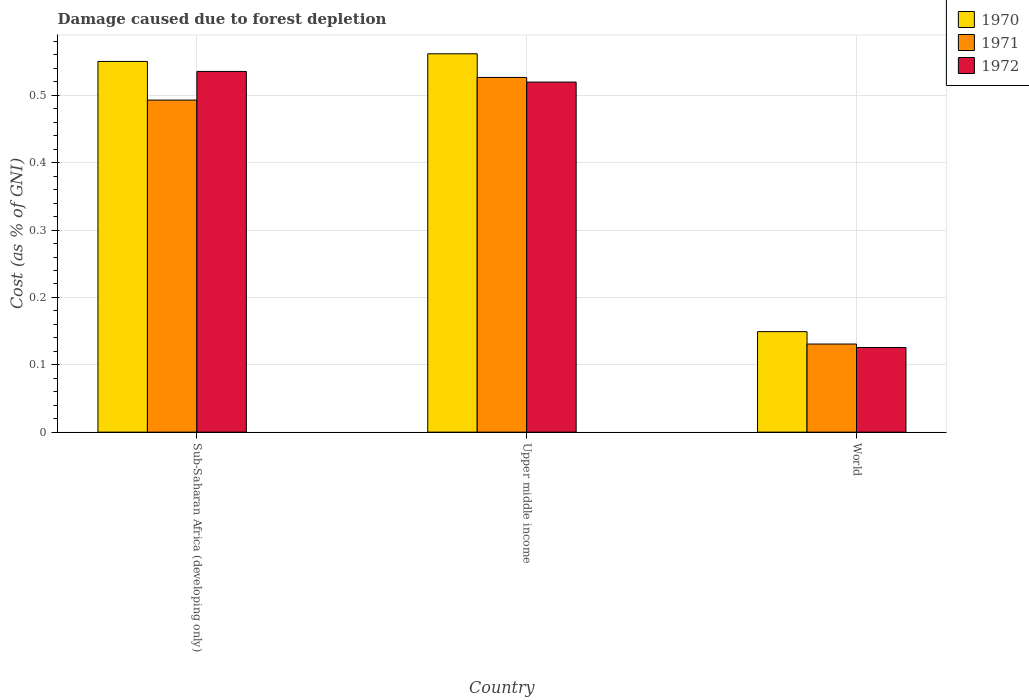How many different coloured bars are there?
Make the answer very short. 3. How many groups of bars are there?
Your answer should be compact. 3. Are the number of bars per tick equal to the number of legend labels?
Your answer should be compact. Yes. How many bars are there on the 2nd tick from the left?
Make the answer very short. 3. How many bars are there on the 2nd tick from the right?
Your answer should be compact. 3. What is the label of the 3rd group of bars from the left?
Your answer should be very brief. World. What is the cost of damage caused due to forest depletion in 1971 in Sub-Saharan Africa (developing only)?
Your answer should be compact. 0.49. Across all countries, what is the maximum cost of damage caused due to forest depletion in 1971?
Provide a succinct answer. 0.53. Across all countries, what is the minimum cost of damage caused due to forest depletion in 1971?
Keep it short and to the point. 0.13. In which country was the cost of damage caused due to forest depletion in 1972 maximum?
Give a very brief answer. Sub-Saharan Africa (developing only). What is the total cost of damage caused due to forest depletion in 1971 in the graph?
Ensure brevity in your answer.  1.15. What is the difference between the cost of damage caused due to forest depletion in 1970 in Upper middle income and that in World?
Provide a succinct answer. 0.41. What is the difference between the cost of damage caused due to forest depletion in 1970 in Sub-Saharan Africa (developing only) and the cost of damage caused due to forest depletion in 1971 in World?
Offer a very short reply. 0.42. What is the average cost of damage caused due to forest depletion in 1970 per country?
Make the answer very short. 0.42. What is the difference between the cost of damage caused due to forest depletion of/in 1971 and cost of damage caused due to forest depletion of/in 1970 in Sub-Saharan Africa (developing only)?
Provide a succinct answer. -0.06. What is the ratio of the cost of damage caused due to forest depletion in 1972 in Upper middle income to that in World?
Keep it short and to the point. 4.14. Is the difference between the cost of damage caused due to forest depletion in 1971 in Sub-Saharan Africa (developing only) and World greater than the difference between the cost of damage caused due to forest depletion in 1970 in Sub-Saharan Africa (developing only) and World?
Make the answer very short. No. What is the difference between the highest and the second highest cost of damage caused due to forest depletion in 1970?
Give a very brief answer. 0.01. What is the difference between the highest and the lowest cost of damage caused due to forest depletion in 1972?
Your answer should be compact. 0.41. In how many countries, is the cost of damage caused due to forest depletion in 1972 greater than the average cost of damage caused due to forest depletion in 1972 taken over all countries?
Ensure brevity in your answer.  2. Is the sum of the cost of damage caused due to forest depletion in 1970 in Sub-Saharan Africa (developing only) and Upper middle income greater than the maximum cost of damage caused due to forest depletion in 1971 across all countries?
Your answer should be compact. Yes. What does the 2nd bar from the left in Sub-Saharan Africa (developing only) represents?
Ensure brevity in your answer.  1971. What does the 1st bar from the right in Upper middle income represents?
Keep it short and to the point. 1972. How many bars are there?
Offer a very short reply. 9. Are all the bars in the graph horizontal?
Offer a terse response. No. What is the difference between two consecutive major ticks on the Y-axis?
Provide a succinct answer. 0.1. Does the graph contain grids?
Ensure brevity in your answer.  Yes. What is the title of the graph?
Give a very brief answer. Damage caused due to forest depletion. Does "1981" appear as one of the legend labels in the graph?
Make the answer very short. No. What is the label or title of the Y-axis?
Keep it short and to the point. Cost (as % of GNI). What is the Cost (as % of GNI) of 1970 in Sub-Saharan Africa (developing only)?
Keep it short and to the point. 0.55. What is the Cost (as % of GNI) of 1971 in Sub-Saharan Africa (developing only)?
Offer a terse response. 0.49. What is the Cost (as % of GNI) in 1972 in Sub-Saharan Africa (developing only)?
Your response must be concise. 0.54. What is the Cost (as % of GNI) of 1970 in Upper middle income?
Your answer should be compact. 0.56. What is the Cost (as % of GNI) in 1971 in Upper middle income?
Keep it short and to the point. 0.53. What is the Cost (as % of GNI) in 1972 in Upper middle income?
Keep it short and to the point. 0.52. What is the Cost (as % of GNI) in 1970 in World?
Offer a very short reply. 0.15. What is the Cost (as % of GNI) in 1971 in World?
Offer a very short reply. 0.13. What is the Cost (as % of GNI) of 1972 in World?
Offer a terse response. 0.13. Across all countries, what is the maximum Cost (as % of GNI) of 1970?
Make the answer very short. 0.56. Across all countries, what is the maximum Cost (as % of GNI) of 1971?
Keep it short and to the point. 0.53. Across all countries, what is the maximum Cost (as % of GNI) of 1972?
Make the answer very short. 0.54. Across all countries, what is the minimum Cost (as % of GNI) in 1970?
Offer a very short reply. 0.15. Across all countries, what is the minimum Cost (as % of GNI) in 1971?
Your answer should be very brief. 0.13. Across all countries, what is the minimum Cost (as % of GNI) in 1972?
Provide a short and direct response. 0.13. What is the total Cost (as % of GNI) in 1970 in the graph?
Ensure brevity in your answer.  1.26. What is the total Cost (as % of GNI) in 1971 in the graph?
Make the answer very short. 1.15. What is the total Cost (as % of GNI) of 1972 in the graph?
Make the answer very short. 1.18. What is the difference between the Cost (as % of GNI) of 1970 in Sub-Saharan Africa (developing only) and that in Upper middle income?
Offer a terse response. -0.01. What is the difference between the Cost (as % of GNI) of 1971 in Sub-Saharan Africa (developing only) and that in Upper middle income?
Provide a succinct answer. -0.03. What is the difference between the Cost (as % of GNI) of 1972 in Sub-Saharan Africa (developing only) and that in Upper middle income?
Your response must be concise. 0.02. What is the difference between the Cost (as % of GNI) of 1970 in Sub-Saharan Africa (developing only) and that in World?
Offer a terse response. 0.4. What is the difference between the Cost (as % of GNI) of 1971 in Sub-Saharan Africa (developing only) and that in World?
Your answer should be very brief. 0.36. What is the difference between the Cost (as % of GNI) in 1972 in Sub-Saharan Africa (developing only) and that in World?
Provide a short and direct response. 0.41. What is the difference between the Cost (as % of GNI) in 1970 in Upper middle income and that in World?
Ensure brevity in your answer.  0.41. What is the difference between the Cost (as % of GNI) of 1971 in Upper middle income and that in World?
Provide a succinct answer. 0.4. What is the difference between the Cost (as % of GNI) in 1972 in Upper middle income and that in World?
Your answer should be very brief. 0.39. What is the difference between the Cost (as % of GNI) of 1970 in Sub-Saharan Africa (developing only) and the Cost (as % of GNI) of 1971 in Upper middle income?
Provide a short and direct response. 0.02. What is the difference between the Cost (as % of GNI) of 1970 in Sub-Saharan Africa (developing only) and the Cost (as % of GNI) of 1972 in Upper middle income?
Provide a succinct answer. 0.03. What is the difference between the Cost (as % of GNI) of 1971 in Sub-Saharan Africa (developing only) and the Cost (as % of GNI) of 1972 in Upper middle income?
Your answer should be very brief. -0.03. What is the difference between the Cost (as % of GNI) of 1970 in Sub-Saharan Africa (developing only) and the Cost (as % of GNI) of 1971 in World?
Give a very brief answer. 0.42. What is the difference between the Cost (as % of GNI) in 1970 in Sub-Saharan Africa (developing only) and the Cost (as % of GNI) in 1972 in World?
Your answer should be compact. 0.42. What is the difference between the Cost (as % of GNI) in 1971 in Sub-Saharan Africa (developing only) and the Cost (as % of GNI) in 1972 in World?
Your answer should be compact. 0.37. What is the difference between the Cost (as % of GNI) of 1970 in Upper middle income and the Cost (as % of GNI) of 1971 in World?
Make the answer very short. 0.43. What is the difference between the Cost (as % of GNI) in 1970 in Upper middle income and the Cost (as % of GNI) in 1972 in World?
Your response must be concise. 0.44. What is the difference between the Cost (as % of GNI) of 1971 in Upper middle income and the Cost (as % of GNI) of 1972 in World?
Provide a succinct answer. 0.4. What is the average Cost (as % of GNI) of 1970 per country?
Provide a short and direct response. 0.42. What is the average Cost (as % of GNI) of 1971 per country?
Offer a very short reply. 0.38. What is the average Cost (as % of GNI) in 1972 per country?
Provide a succinct answer. 0.39. What is the difference between the Cost (as % of GNI) of 1970 and Cost (as % of GNI) of 1971 in Sub-Saharan Africa (developing only)?
Keep it short and to the point. 0.06. What is the difference between the Cost (as % of GNI) of 1970 and Cost (as % of GNI) of 1972 in Sub-Saharan Africa (developing only)?
Offer a very short reply. 0.01. What is the difference between the Cost (as % of GNI) in 1971 and Cost (as % of GNI) in 1972 in Sub-Saharan Africa (developing only)?
Ensure brevity in your answer.  -0.04. What is the difference between the Cost (as % of GNI) of 1970 and Cost (as % of GNI) of 1971 in Upper middle income?
Offer a terse response. 0.04. What is the difference between the Cost (as % of GNI) in 1970 and Cost (as % of GNI) in 1972 in Upper middle income?
Your response must be concise. 0.04. What is the difference between the Cost (as % of GNI) of 1971 and Cost (as % of GNI) of 1972 in Upper middle income?
Offer a very short reply. 0.01. What is the difference between the Cost (as % of GNI) of 1970 and Cost (as % of GNI) of 1971 in World?
Provide a short and direct response. 0.02. What is the difference between the Cost (as % of GNI) of 1970 and Cost (as % of GNI) of 1972 in World?
Your response must be concise. 0.02. What is the difference between the Cost (as % of GNI) of 1971 and Cost (as % of GNI) of 1972 in World?
Offer a terse response. 0.01. What is the ratio of the Cost (as % of GNI) in 1970 in Sub-Saharan Africa (developing only) to that in Upper middle income?
Keep it short and to the point. 0.98. What is the ratio of the Cost (as % of GNI) of 1971 in Sub-Saharan Africa (developing only) to that in Upper middle income?
Your answer should be very brief. 0.94. What is the ratio of the Cost (as % of GNI) in 1972 in Sub-Saharan Africa (developing only) to that in Upper middle income?
Ensure brevity in your answer.  1.03. What is the ratio of the Cost (as % of GNI) of 1970 in Sub-Saharan Africa (developing only) to that in World?
Your response must be concise. 3.69. What is the ratio of the Cost (as % of GNI) of 1971 in Sub-Saharan Africa (developing only) to that in World?
Give a very brief answer. 3.77. What is the ratio of the Cost (as % of GNI) of 1972 in Sub-Saharan Africa (developing only) to that in World?
Your answer should be very brief. 4.26. What is the ratio of the Cost (as % of GNI) in 1970 in Upper middle income to that in World?
Give a very brief answer. 3.76. What is the ratio of the Cost (as % of GNI) in 1971 in Upper middle income to that in World?
Your answer should be compact. 4.03. What is the ratio of the Cost (as % of GNI) in 1972 in Upper middle income to that in World?
Offer a terse response. 4.14. What is the difference between the highest and the second highest Cost (as % of GNI) in 1970?
Ensure brevity in your answer.  0.01. What is the difference between the highest and the second highest Cost (as % of GNI) in 1971?
Offer a terse response. 0.03. What is the difference between the highest and the second highest Cost (as % of GNI) of 1972?
Your answer should be very brief. 0.02. What is the difference between the highest and the lowest Cost (as % of GNI) in 1970?
Your answer should be compact. 0.41. What is the difference between the highest and the lowest Cost (as % of GNI) of 1971?
Your response must be concise. 0.4. What is the difference between the highest and the lowest Cost (as % of GNI) of 1972?
Provide a short and direct response. 0.41. 